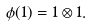Convert formula to latex. <formula><loc_0><loc_0><loc_500><loc_500>\phi ( 1 ) = 1 \otimes 1 .</formula> 